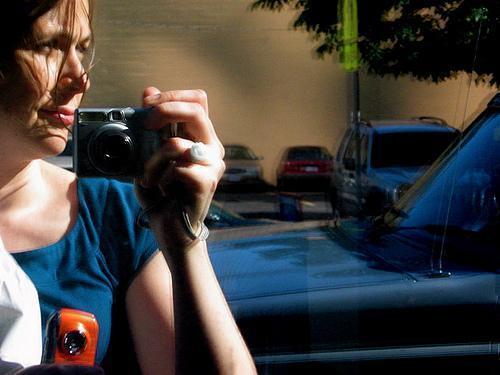What can be done using the orange thing?
Answer the question by selecting the correct answer among the 4 following choices and explain your choice with a short sentence. The answer should be formatted with the following format: `Answer: choice
Rationale: rationale.`
Options: Fly around, lock house, eat food, take pictures. Answer: take pictures.
Rationale: It has a lens on it.  you can use it to take a picture. 